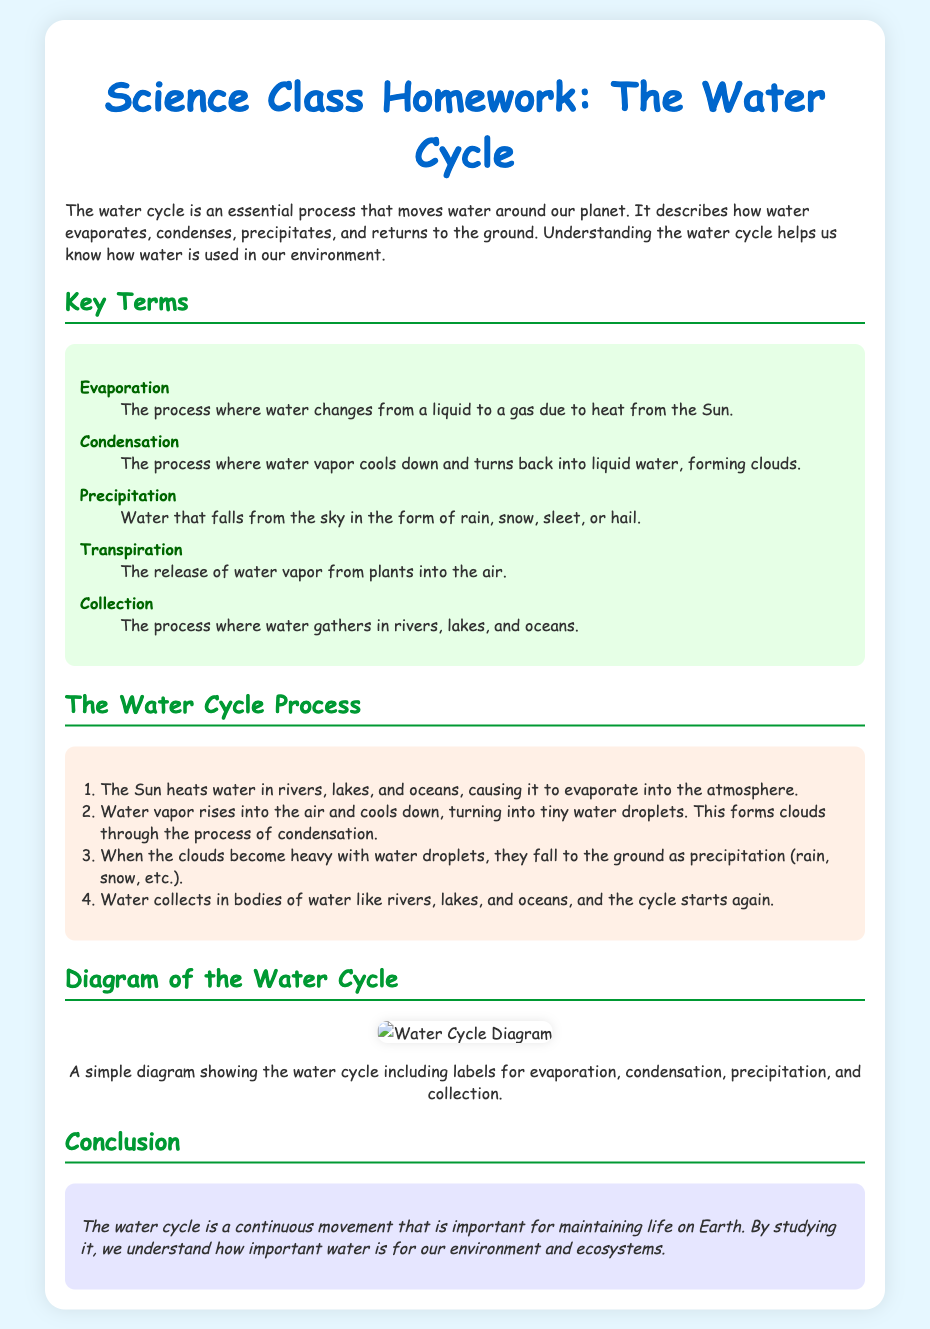What is the title of the document? The title of the document indicates the main topic covered in the note, which is "The Water Cycle - Science Class Homework."
Answer: The Water Cycle - Science Class Homework What is evaporation? Evaporation is defined in the document as "the process where water changes from a liquid to a gas due to heat from the Sun."
Answer: The process where water changes from a liquid to a gas due to heat from the Sun How many steps are in the water cycle process? The document lists four steps in the water cycle process as part of its explanation.
Answer: Four What falls from the sky as precipitation? The document mentions that precipitation can fall in various forms including rain, snow, sleet, or hail, specifying the types of precipitation.
Answer: Rain, snow, sleet, or hail What is the main role of the Sun in the water cycle? The document states that the Sun heats water in rivers, lakes, and oceans, which causes evaporation.
Answer: Heats water What is collected in rivers, lakes, and oceans? According to the document, water is gathered during the collection stage of the water cycle.
Answer: Water What happens when clouds become heavy? The document explains that when clouds become heavy with water droplets, they fall to the ground as precipitation.
Answer: They fall to the ground as precipitation Which process involves water vapor cooling down? Condensation is the defined process where water vapor cools down and turns back into liquid water, forming clouds.
Answer: Condensation What is the background color of the document? The background color of the document is described as light blue in the style section of the code.
Answer: Light blue 